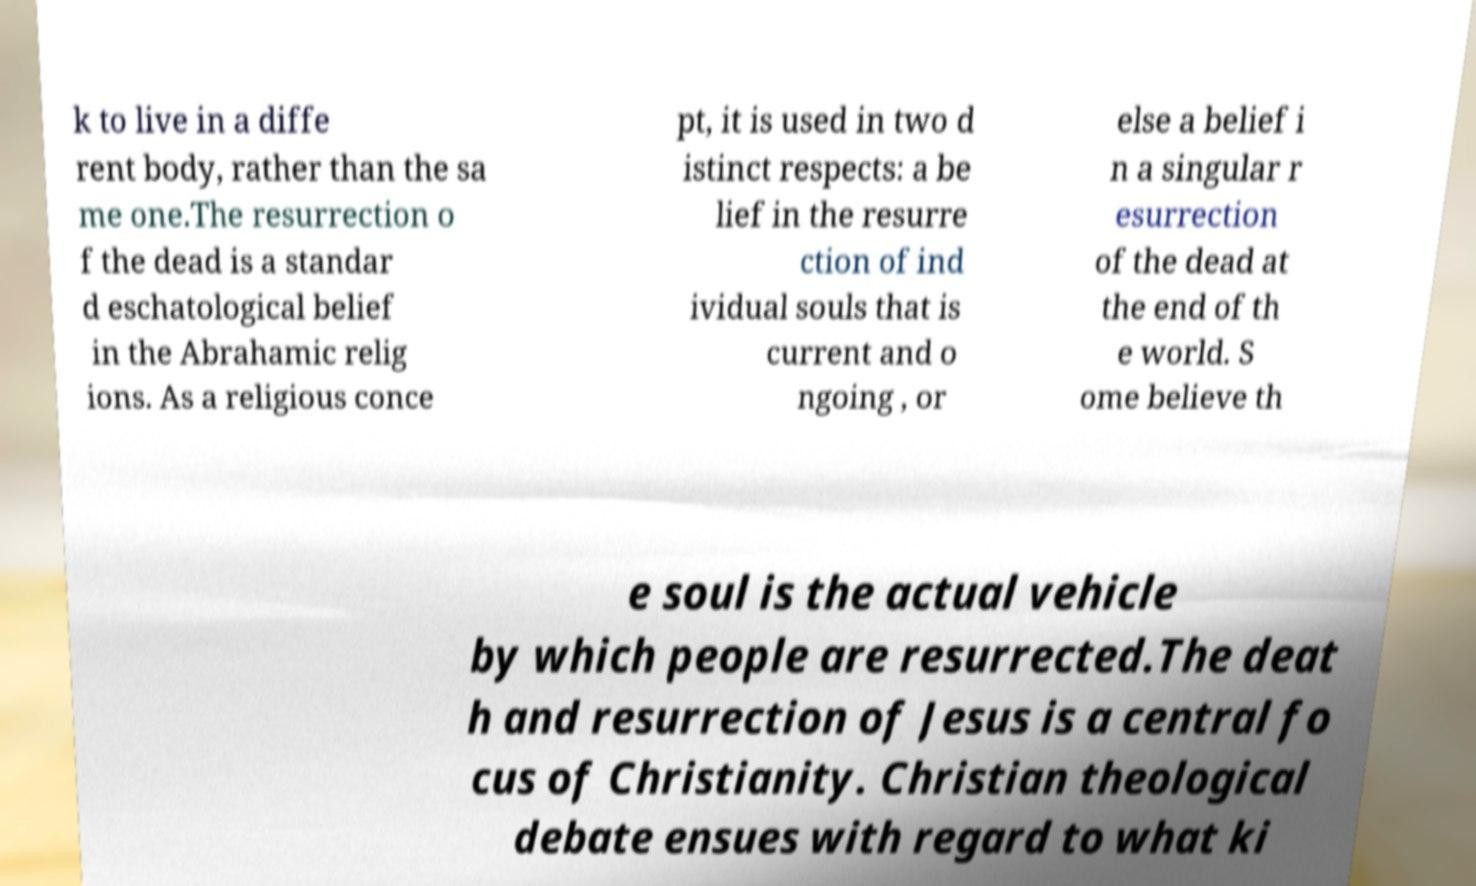Can you accurately transcribe the text from the provided image for me? k to live in a diffe rent body, rather than the sa me one.The resurrection o f the dead is a standar d eschatological belief in the Abrahamic relig ions. As a religious conce pt, it is used in two d istinct respects: a be lief in the resurre ction of ind ividual souls that is current and o ngoing , or else a belief i n a singular r esurrection of the dead at the end of th e world. S ome believe th e soul is the actual vehicle by which people are resurrected.The deat h and resurrection of Jesus is a central fo cus of Christianity. Christian theological debate ensues with regard to what ki 